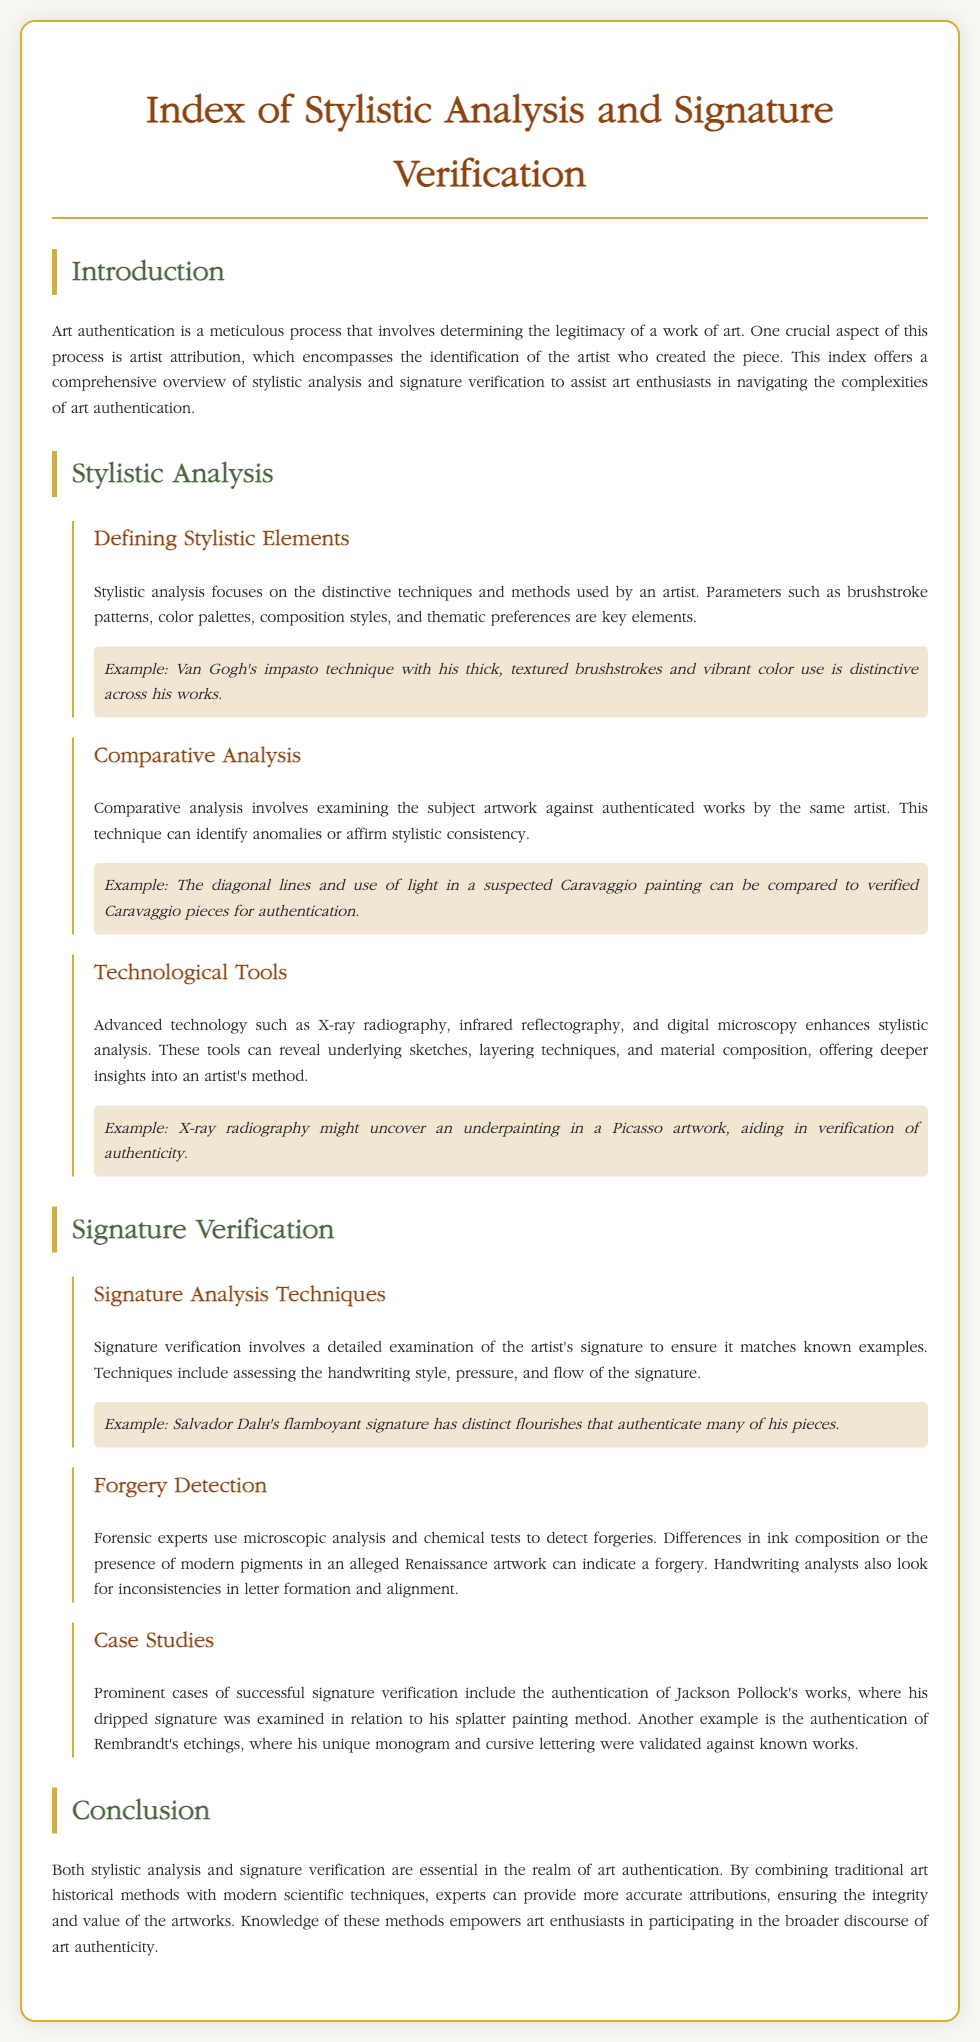what is the title of the document? The title of the document, as stated in the header, is "Index of Stylistic Analysis and Signature Verification".
Answer: Index of Stylistic Analysis and Signature Verification who is the example artist mentioned for impasto technique? The document provides Van Gogh as an example artist known for his impasto technique.
Answer: Van Gogh what tool enhances stylistic analysis? The document lists advanced technology such as X-ray radiography as a tool enhancing stylistic analysis.
Answer: X-ray radiography which artist has a flamboyant signature? Salvador Dalí is mentioned in the document as the artist with a flamboyant signature.
Answer: Salvador Dalí how did the document describe signature verification? The document describes signature verification involving a detailed examination of the artist's signature to match known examples.
Answer: Detailed examination what is one method for detecting forgeries? According to the document, microscopic analysis is one method used for detecting forgeries.
Answer: Microscopic analysis which artist’s works were authenticated based on splatter painting method? Jackson Pollock's works were authenticated based on his dripped signature related to his splatter painting method.
Answer: Jackson Pollock what are the two main components mentioned for art authentication? The document identifies stylistic analysis and signature verification as the two main components for art authentication.
Answer: Stylistic analysis and signature verification how does stylistic analysis contribute to authentication? Stylistic analysis contributes to authentication by examining distinctive techniques and methods used by an artist.
Answer: Examining distinctive techniques and methods 